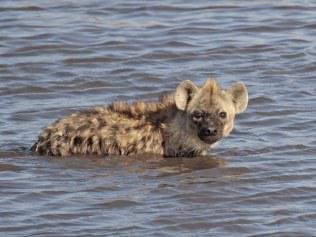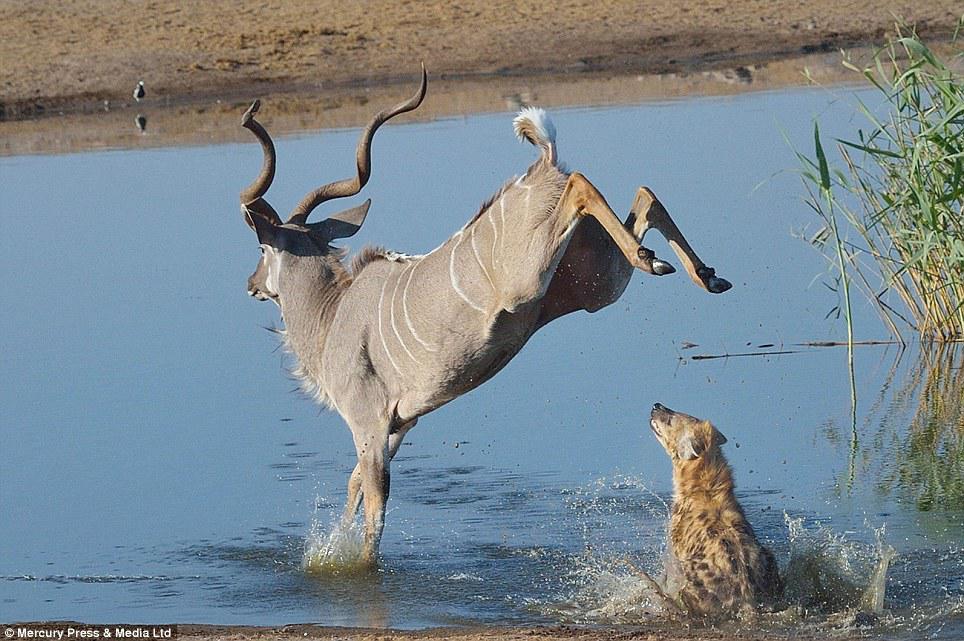The first image is the image on the left, the second image is the image on the right. Given the left and right images, does the statement "An image shows at least three hyenas in the water." hold true? Answer yes or no. No. The first image is the image on the left, the second image is the image on the right. For the images shown, is this caption "There are at least two hyenas in the water in the image on the right." true? Answer yes or no. No. 